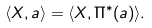<formula> <loc_0><loc_0><loc_500><loc_500>\langle X , a \rangle = \langle X , \Pi ^ { * } ( a ) \rangle .</formula> 